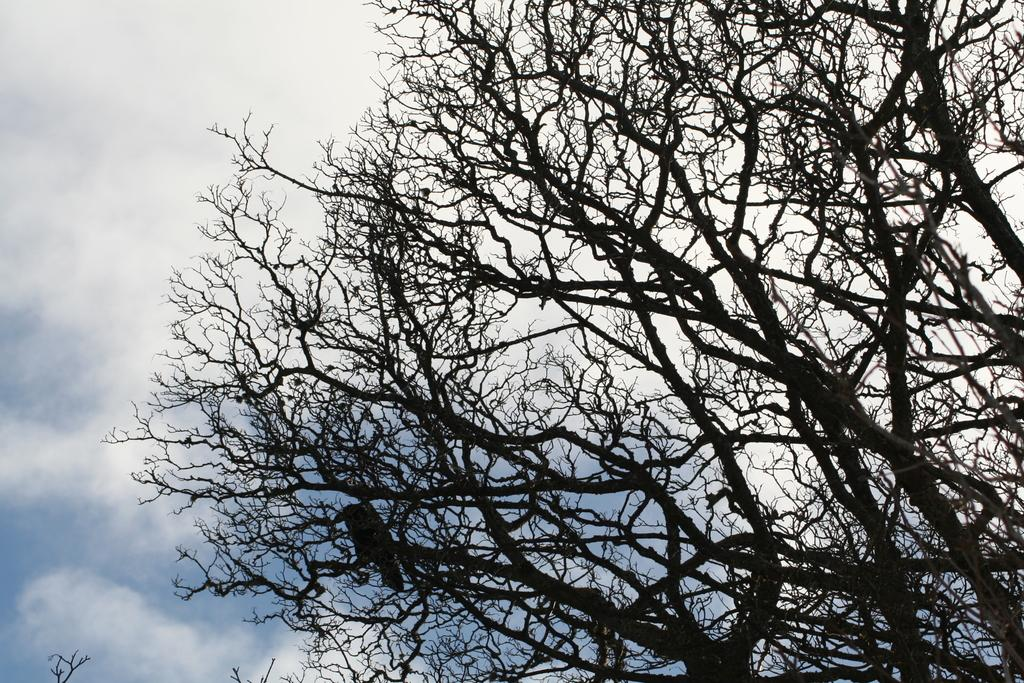What type of tree is in the image? There is a dry tree in the image. Can you describe any living organisms present on the tree? Yes, a bird is present on the tree. Where is the squirrel located in the image? There is no squirrel present in the image. What type of border surrounds the tree in the image? There is no border present in the image. What type of alley is visible in the image? There is no alley present in the image. 